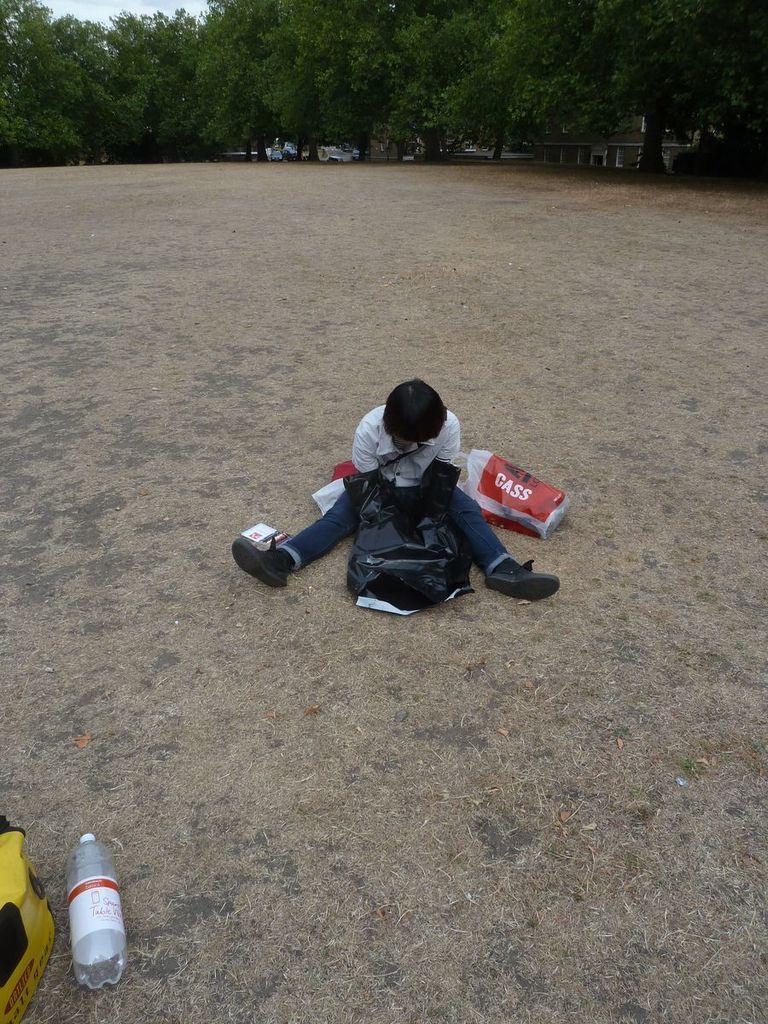How would you summarize this image in a sentence or two? Here we can see a person sitting on the ground. There are bags and a bottle. In the background we can see trees, vehicles, and sky. 